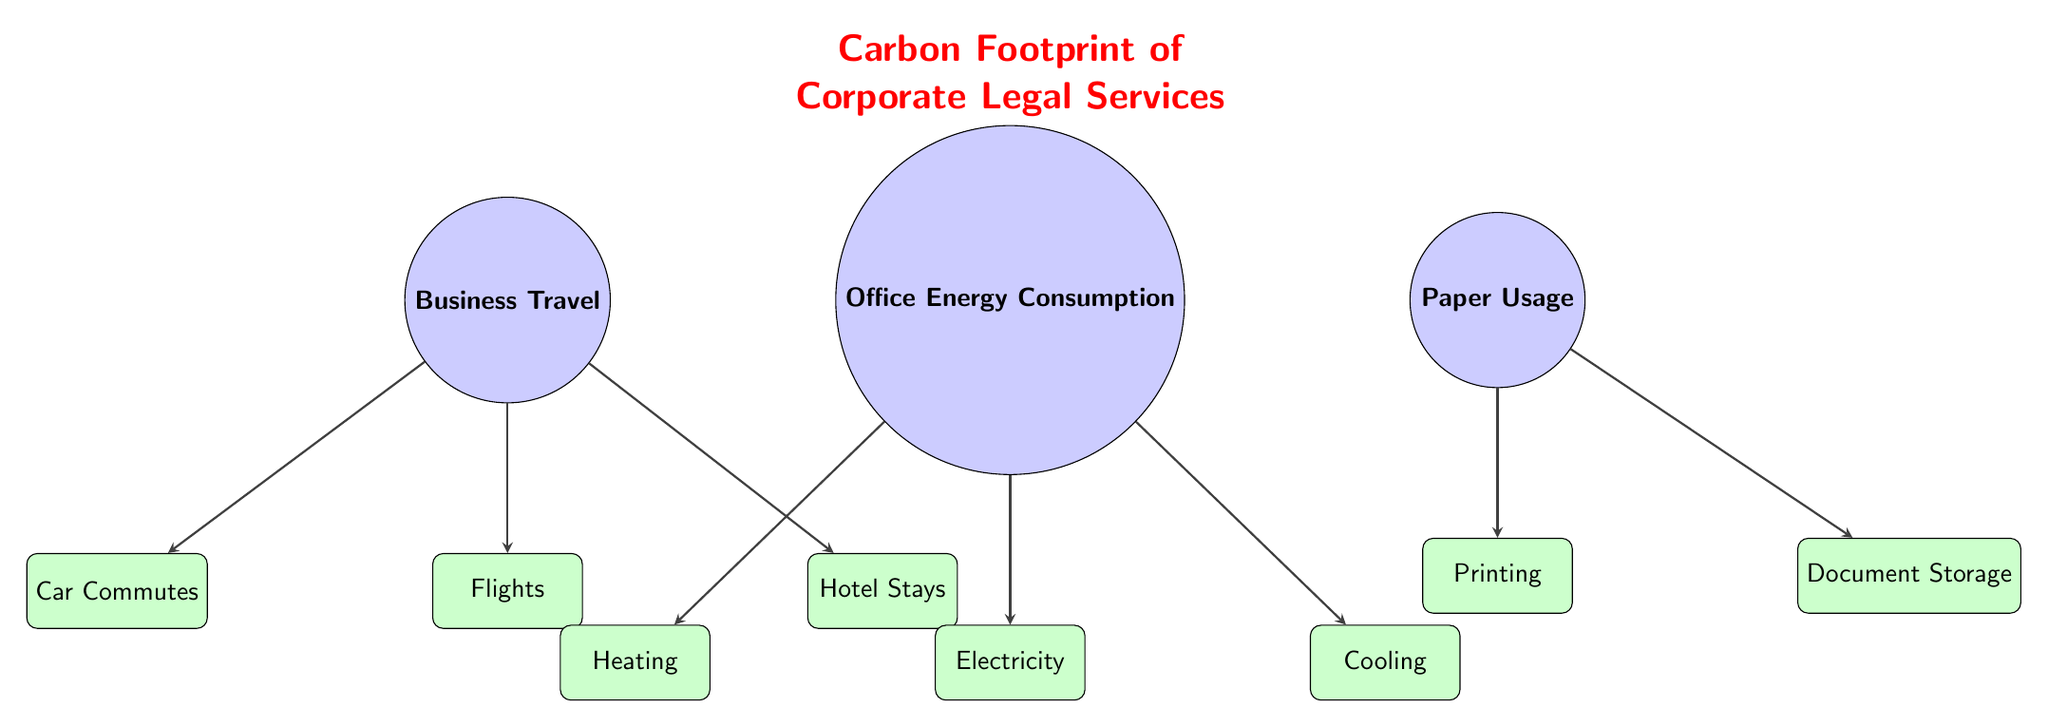What are the three main categories of carbon footprint in the diagram? The diagram contains three main categories represented by the main nodes: Business Travel, Office Energy Consumption, and Paper Usage.
Answer: Business Travel, Office Energy Consumption, Paper Usage How many subcategories are listed under Business Travel? The subcategories listed under Business Travel are Flights, Car Commutes, and Hotel Stays, which makes a total of three subcategories.
Answer: 3 Which main category contributes the most to greenhouse gas emissions? While the diagram does not provide numerical values, it implies that each main category may contribute differently to emissions; however, there are no clear indicators to determine which one contributes the most.
Answer: Not specified Which subcategory is associated with Office Energy Consumption? The subcategories associated with Office Energy Consumption are Electricity, Heating, and Cooling as indicated by the arrows leading from the main node.
Answer: Electricity, Heating, Cooling How are subcategories visually connected to their main category in the diagram? Subcategories are visually connected to their respective main categories through directed arrows, which indicate the flow of emissions data from the main category to its detailed subcategories.
Answer: Directed arrows What is the relationship between Paper Usage and its subcategories? Paper Usage has two subcategories, Printing and Document Storage, which are directly connected by arrows, signifying their roles in contributing to the carbon footprint of this category.
Answer: Printing, Document Storage What can be inferred about the role of Business Travel in a corporate law firm's carbon footprint? Business Travel, having its own main category and three significant subcategories, suggests that it has a considerable impact on the carbon footprint, highlighting the importance of managing travel emissions.
Answer: Significant impact How many total subcategories exist in the diagram? The diagram features three subcategories under Business Travel, three under Office Energy Consumption, and two under Paper Usage, resulting in a total of eight subcategories.
Answer: 8 